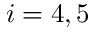Convert formula to latex. <formula><loc_0><loc_0><loc_500><loc_500>i = 4 , 5</formula> 